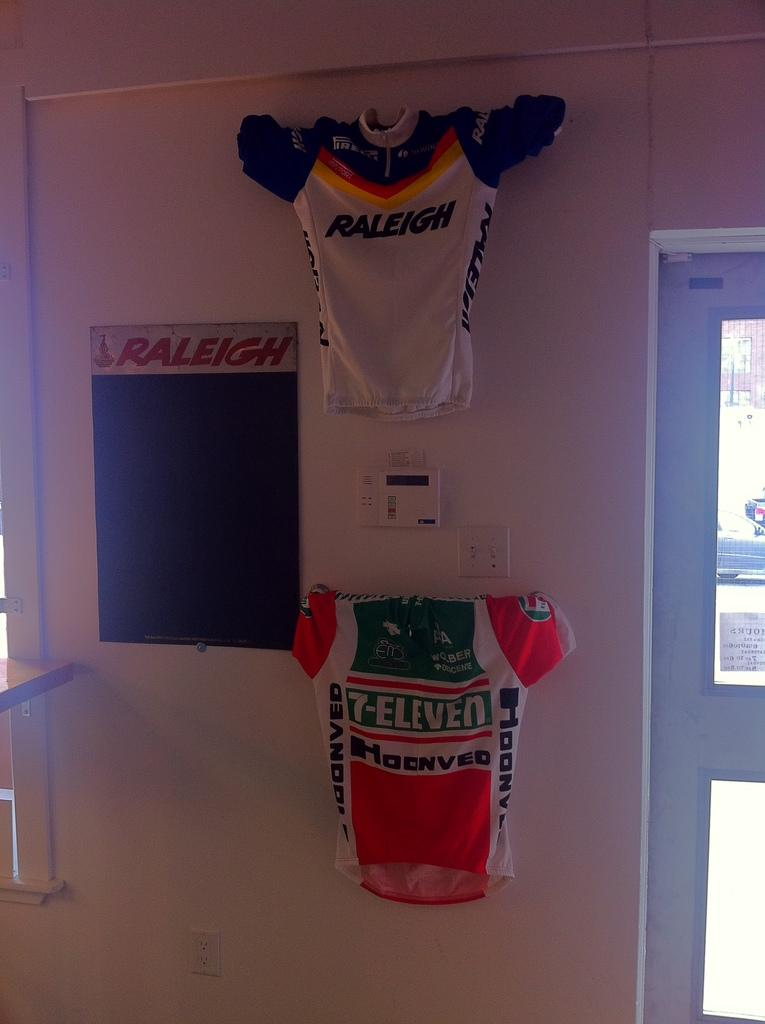Provide a one-sentence caption for the provided image. a couple of jerseys one that says Raleigh on it. 